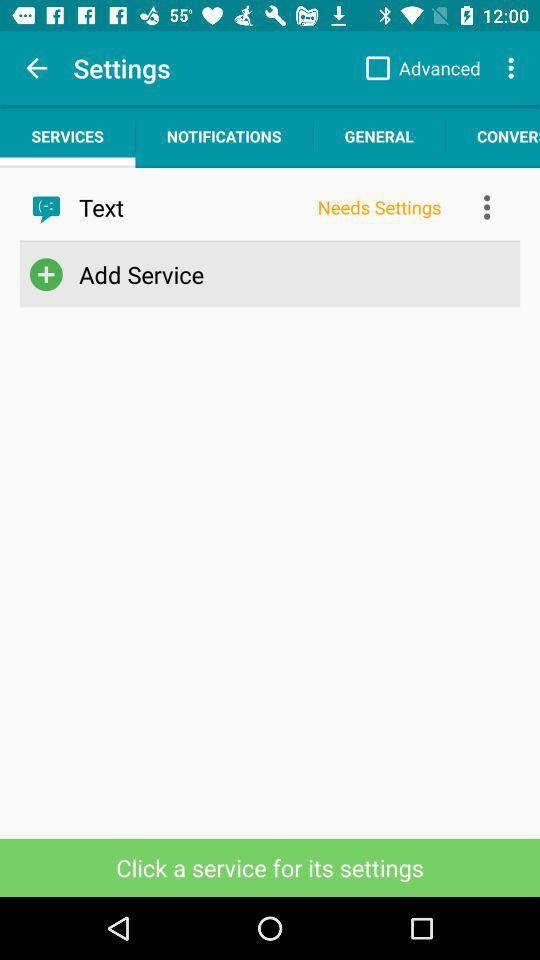Which tab is selected? The selected tab is "SERVICES". 